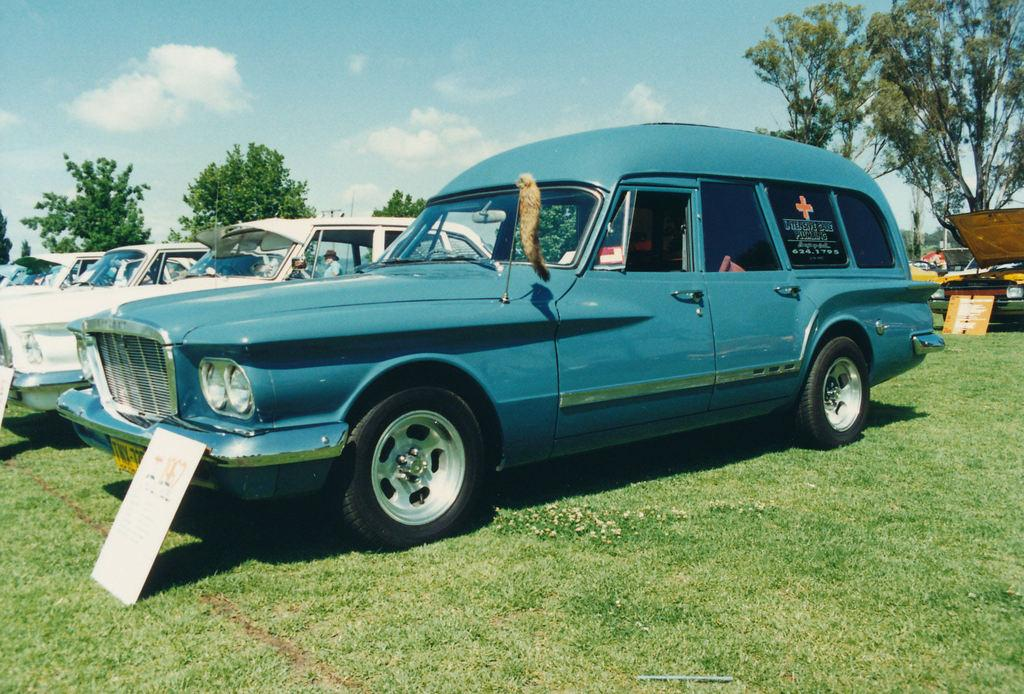What is located in the center of the image? There are vehicles and banners in the center of the image. What can be seen in the background of the image? The sky, clouds, trees, grass, and a person are visible in the background of the image. There are also other objects present. Can you describe the weather conditions in the image? The presence of clouds in the sky suggests that it might be partly cloudy. How many copies of the bubble are being exchanged in the image? There is no mention of a bubble or any exchange in the image. 